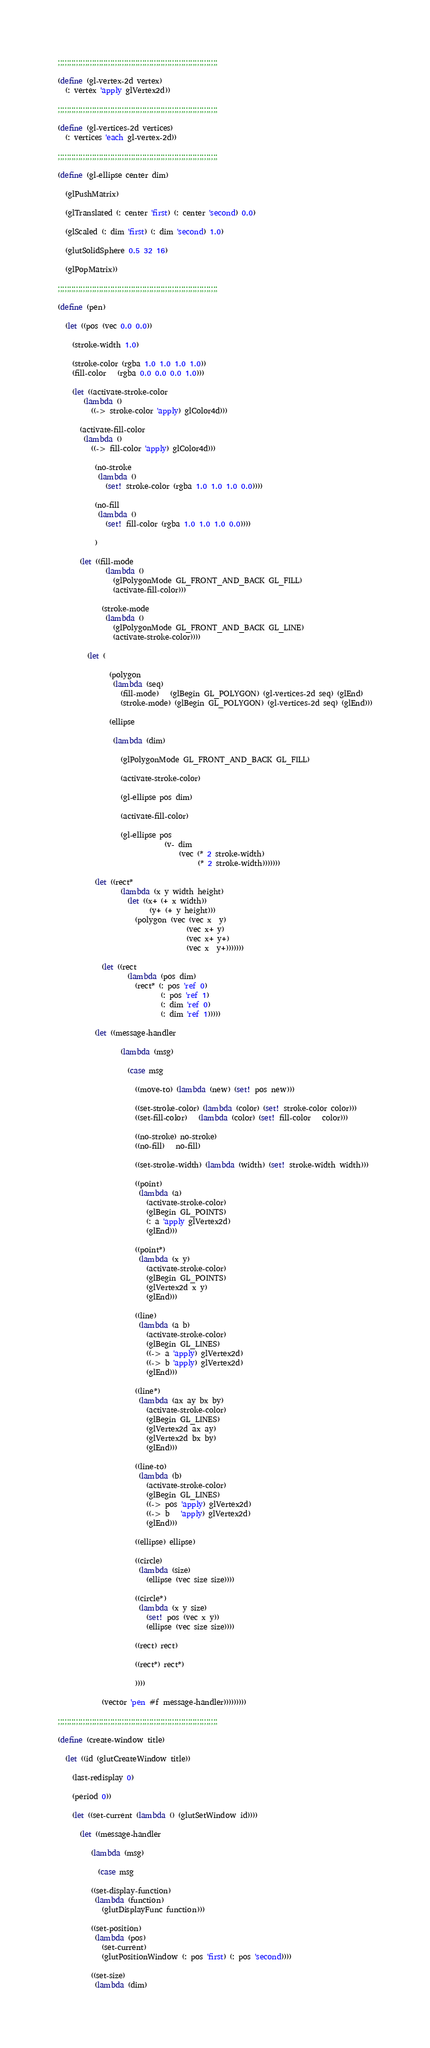Convert code to text. <code><loc_0><loc_0><loc_500><loc_500><_Scheme_>
;;;;;;;;;;;;;;;;;;;;;;;;;;;;;;;;;;;;;;;;;;;;;;;;;;;;;;;;;;;;;;;;;;;;;;

(define (gl-vertex-2d vertex)
  (: vertex 'apply glVertex2d))

;;;;;;;;;;;;;;;;;;;;;;;;;;;;;;;;;;;;;;;;;;;;;;;;;;;;;;;;;;;;;;;;;;;;;;

(define (gl-vertices-2d vertices)
  (: vertices 'each gl-vertex-2d))

;;;;;;;;;;;;;;;;;;;;;;;;;;;;;;;;;;;;;;;;;;;;;;;;;;;;;;;;;;;;;;;;;;;;;;

(define (gl-ellipse center dim)

  (glPushMatrix)

  (glTranslated (: center 'first) (: center 'second) 0.0)

  (glScaled (: dim 'first) (: dim 'second) 1.0)

  (glutSolidSphere 0.5 32 16)

  (glPopMatrix))

;;;;;;;;;;;;;;;;;;;;;;;;;;;;;;;;;;;;;;;;;;;;;;;;;;;;;;;;;;;;;;;;;;;;;;

(define (pen)

  (let ((pos (vec 0.0 0.0))

	(stroke-width 1.0)

	(stroke-color (rgba 1.0 1.0 1.0 1.0))
	(fill-color   (rgba 0.0 0.0 0.0 1.0)))

    (let ((activate-stroke-color
	   (lambda ()
	     ((-> stroke-color 'apply) glColor4d)))

	  (activate-fill-color
	   (lambda ()
	     ((-> fill-color 'apply) glColor4d)))

          (no-stroke
           (lambda ()
             (set! stroke-color (rgba 1.0 1.0 1.0 0.0))))

          (no-fill
           (lambda ()
             (set! fill-color (rgba 1.0 1.0 1.0 0.0))))
          
          )

      (let ((fill-mode
             (lambda ()
               (glPolygonMode GL_FRONT_AND_BACK GL_FILL)
               (activate-fill-color)))
            
            (stroke-mode
             (lambda ()
               (glPolygonMode GL_FRONT_AND_BACK GL_LINE)
               (activate-stroke-color))))

        (let (

              (polygon
               (lambda (seq)
                 (fill-mode)   (glBegin GL_POLYGON) (gl-vertices-2d seq) (glEnd)
                 (stroke-mode) (glBegin GL_POLYGON) (gl-vertices-2d seq) (glEnd)))

              (ellipse

               (lambda (dim)

                 (glPolygonMode GL_FRONT_AND_BACK GL_FILL)

                 (activate-stroke-color)

                 (gl-ellipse pos dim)
                 
                 (activate-fill-color)

                 (gl-ellipse pos 
                             (v- dim
                                 (vec (* 2 stroke-width)
                                      (* 2 stroke-width)))))))

          (let ((rect*
                 (lambda (x y width height)
                   (let ((x+ (+ x width))
                         (y+ (+ y height)))
                     (polygon (vec (vec x  y)
                                   (vec x+ y)
                                   (vec x+ y+)
                                   (vec x  y+)))))))

            (let ((rect
                   (lambda (pos dim)
                     (rect* (: pos 'ref 0)
                            (: pos 'ref 1)
                            (: dim 'ref 0)
                            (: dim 'ref 1)))))

          (let ((message-handler

                 (lambda (msg)

                   (case msg

                     ((move-to) (lambda (new) (set! pos new)))

                     ((set-stroke-color) (lambda (color) (set! stroke-color color)))
                     ((set-fill-color)   (lambda (color) (set! fill-color   color)))

                     ((no-stroke) no-stroke)
                     ((no-fill)   no-fill)

                     ((set-stroke-width) (lambda (width) (set! stroke-width width)))

                     ((point)
                      (lambda (a)
                        (activate-stroke-color)
                        (glBegin GL_POINTS)
                        (: a 'apply glVertex2d)
                        (glEnd)))

                     ((point*)
                      (lambda (x y)
                        (activate-stroke-color)
                        (glBegin GL_POINTS)
                        (glVertex2d x y)
                        (glEnd)))

                     ((line)
                      (lambda (a b)
                        (activate-stroke-color)
                        (glBegin GL_LINES)
                        ((-> a 'apply) glVertex2d)
                        ((-> b 'apply) glVertex2d)
                        (glEnd)))

                     ((line*)
                      (lambda (ax ay bx by)
                        (activate-stroke-color)
                        (glBegin GL_LINES)
                        (glVertex2d ax ay)
                        (glVertex2d bx by)
                        (glEnd)))

                     ((line-to)
                      (lambda (b)
                        (activate-stroke-color)
                        (glBegin GL_LINES)
                        ((-> pos 'apply) glVertex2d)
                        ((-> b   'apply) glVertex2d)
                        (glEnd)))

                     ((ellipse) ellipse)

                     ((circle)
                      (lambda (size)
                        (ellipse (vec size size))))

                     ((circle*)
                      (lambda (x y size)
                        (set! pos (vec x y))
                        (ellipse (vec size size))))

                     ((rect) rect)
                     
                     ((rect*) rect*)

                     ))))

            (vector 'pen #f message-handler)))))))))

;;;;;;;;;;;;;;;;;;;;;;;;;;;;;;;;;;;;;;;;;;;;;;;;;;;;;;;;;;;;;;;;;;;;;;

(define (create-window title)

  (let ((id (glutCreateWindow title))

	(last-redisplay 0)

	(period 0))

    (let ((set-current (lambda () (glutSetWindow id))))

      (let ((message-handler

	     (lambda (msg)

	       (case msg

		 ((set-display-function)
		  (lambda (function)
		    (glutDisplayFunc function)))

		 ((set-position)
		  (lambda (pos)
		    (set-current)
		    (glutPositionWindow (: pos 'first) (: pos 'second))))

		 ((set-size)
		  (lambda (dim)</code> 